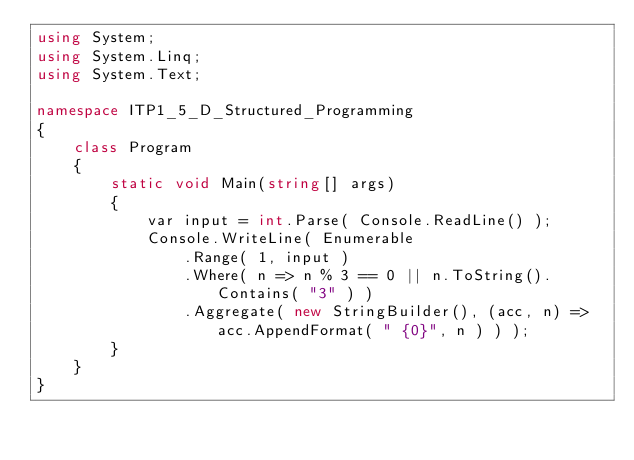Convert code to text. <code><loc_0><loc_0><loc_500><loc_500><_C#_>using System;
using System.Linq;
using System.Text;

namespace ITP1_5_D_Structured_Programming
{
    class Program
    {
        static void Main(string[] args)
        {
            var input = int.Parse( Console.ReadLine() );
            Console.WriteLine( Enumerable
                .Range( 1, input )
                .Where( n => n % 3 == 0 || n.ToString().Contains( "3" ) )
                .Aggregate( new StringBuilder(), (acc, n) => acc.AppendFormat( " {0}", n ) ) );
        }
    }
}</code> 